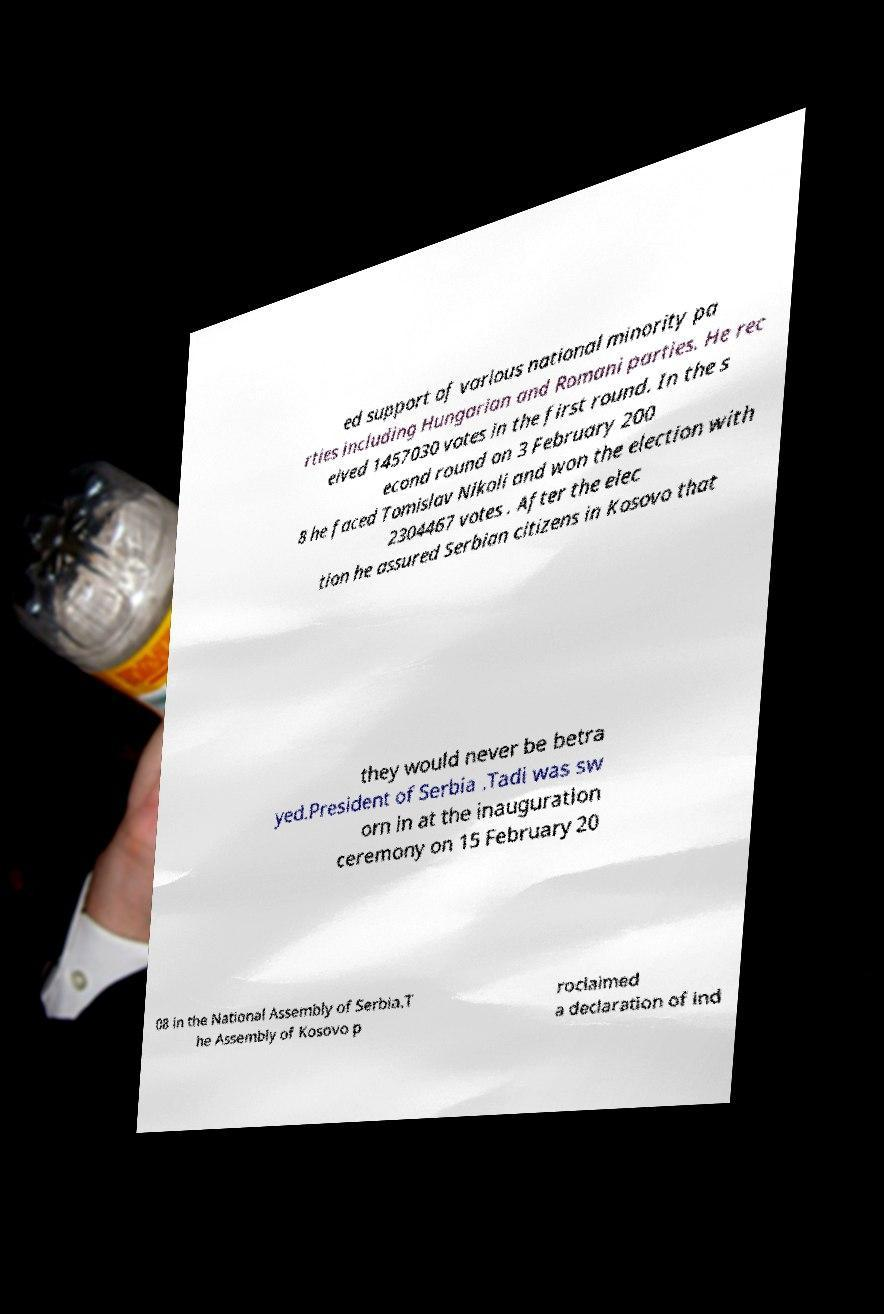Could you assist in decoding the text presented in this image and type it out clearly? ed support of various national minority pa rties including Hungarian and Romani parties. He rec eived 1457030 votes in the first round. In the s econd round on 3 February 200 8 he faced Tomislav Nikoli and won the election with 2304467 votes . After the elec tion he assured Serbian citizens in Kosovo that they would never be betra yed.President of Serbia .Tadi was sw orn in at the inauguration ceremony on 15 February 20 08 in the National Assembly of Serbia.T he Assembly of Kosovo p roclaimed a declaration of ind 